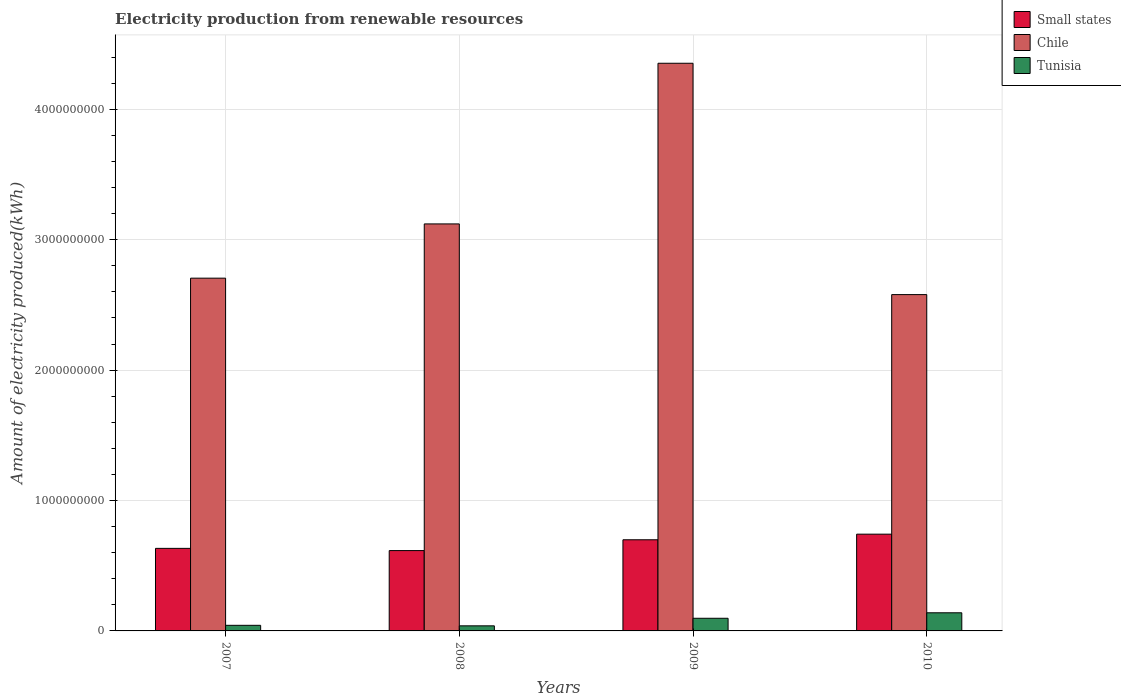How many different coloured bars are there?
Ensure brevity in your answer.  3. How many groups of bars are there?
Provide a short and direct response. 4. How many bars are there on the 2nd tick from the right?
Provide a short and direct response. 3. What is the label of the 1st group of bars from the left?
Your answer should be very brief. 2007. What is the amount of electricity produced in Tunisia in 2008?
Offer a very short reply. 3.90e+07. Across all years, what is the maximum amount of electricity produced in Tunisia?
Ensure brevity in your answer.  1.39e+08. Across all years, what is the minimum amount of electricity produced in Chile?
Your answer should be compact. 2.58e+09. In which year was the amount of electricity produced in Chile maximum?
Your answer should be compact. 2009. What is the total amount of electricity produced in Chile in the graph?
Offer a terse response. 1.28e+1. What is the difference between the amount of electricity produced in Tunisia in 2008 and that in 2009?
Offer a very short reply. -5.80e+07. What is the difference between the amount of electricity produced in Small states in 2008 and the amount of electricity produced in Tunisia in 2009?
Provide a succinct answer. 5.19e+08. What is the average amount of electricity produced in Small states per year?
Offer a terse response. 6.72e+08. In the year 2008, what is the difference between the amount of electricity produced in Small states and amount of electricity produced in Chile?
Your response must be concise. -2.50e+09. What is the ratio of the amount of electricity produced in Small states in 2008 to that in 2010?
Offer a very short reply. 0.83. Is the difference between the amount of electricity produced in Small states in 2008 and 2010 greater than the difference between the amount of electricity produced in Chile in 2008 and 2010?
Your answer should be compact. No. What is the difference between the highest and the second highest amount of electricity produced in Tunisia?
Provide a short and direct response. 4.20e+07. What is the difference between the highest and the lowest amount of electricity produced in Small states?
Provide a short and direct response. 1.26e+08. Is the sum of the amount of electricity produced in Tunisia in 2008 and 2009 greater than the maximum amount of electricity produced in Small states across all years?
Ensure brevity in your answer.  No. What does the 3rd bar from the left in 2009 represents?
Your answer should be very brief. Tunisia. What is the difference between two consecutive major ticks on the Y-axis?
Make the answer very short. 1.00e+09. How many legend labels are there?
Your answer should be very brief. 3. What is the title of the graph?
Offer a terse response. Electricity production from renewable resources. Does "Afghanistan" appear as one of the legend labels in the graph?
Ensure brevity in your answer.  No. What is the label or title of the X-axis?
Your answer should be compact. Years. What is the label or title of the Y-axis?
Offer a very short reply. Amount of electricity produced(kWh). What is the Amount of electricity produced(kWh) of Small states in 2007?
Ensure brevity in your answer.  6.33e+08. What is the Amount of electricity produced(kWh) in Chile in 2007?
Offer a terse response. 2.70e+09. What is the Amount of electricity produced(kWh) in Tunisia in 2007?
Your answer should be compact. 4.30e+07. What is the Amount of electricity produced(kWh) of Small states in 2008?
Your answer should be compact. 6.16e+08. What is the Amount of electricity produced(kWh) in Chile in 2008?
Your answer should be very brief. 3.12e+09. What is the Amount of electricity produced(kWh) in Tunisia in 2008?
Your answer should be compact. 3.90e+07. What is the Amount of electricity produced(kWh) of Small states in 2009?
Provide a short and direct response. 6.99e+08. What is the Amount of electricity produced(kWh) of Chile in 2009?
Your answer should be compact. 4.35e+09. What is the Amount of electricity produced(kWh) of Tunisia in 2009?
Keep it short and to the point. 9.70e+07. What is the Amount of electricity produced(kWh) in Small states in 2010?
Give a very brief answer. 7.42e+08. What is the Amount of electricity produced(kWh) of Chile in 2010?
Offer a very short reply. 2.58e+09. What is the Amount of electricity produced(kWh) of Tunisia in 2010?
Give a very brief answer. 1.39e+08. Across all years, what is the maximum Amount of electricity produced(kWh) of Small states?
Your response must be concise. 7.42e+08. Across all years, what is the maximum Amount of electricity produced(kWh) of Chile?
Keep it short and to the point. 4.35e+09. Across all years, what is the maximum Amount of electricity produced(kWh) of Tunisia?
Give a very brief answer. 1.39e+08. Across all years, what is the minimum Amount of electricity produced(kWh) of Small states?
Offer a very short reply. 6.16e+08. Across all years, what is the minimum Amount of electricity produced(kWh) in Chile?
Give a very brief answer. 2.58e+09. Across all years, what is the minimum Amount of electricity produced(kWh) of Tunisia?
Offer a terse response. 3.90e+07. What is the total Amount of electricity produced(kWh) in Small states in the graph?
Offer a very short reply. 2.69e+09. What is the total Amount of electricity produced(kWh) of Chile in the graph?
Provide a short and direct response. 1.28e+1. What is the total Amount of electricity produced(kWh) in Tunisia in the graph?
Provide a succinct answer. 3.18e+08. What is the difference between the Amount of electricity produced(kWh) of Small states in 2007 and that in 2008?
Your answer should be very brief. 1.70e+07. What is the difference between the Amount of electricity produced(kWh) of Chile in 2007 and that in 2008?
Your answer should be very brief. -4.16e+08. What is the difference between the Amount of electricity produced(kWh) of Small states in 2007 and that in 2009?
Your answer should be very brief. -6.60e+07. What is the difference between the Amount of electricity produced(kWh) of Chile in 2007 and that in 2009?
Offer a very short reply. -1.65e+09. What is the difference between the Amount of electricity produced(kWh) of Tunisia in 2007 and that in 2009?
Provide a succinct answer. -5.40e+07. What is the difference between the Amount of electricity produced(kWh) of Small states in 2007 and that in 2010?
Your answer should be very brief. -1.09e+08. What is the difference between the Amount of electricity produced(kWh) of Chile in 2007 and that in 2010?
Offer a terse response. 1.26e+08. What is the difference between the Amount of electricity produced(kWh) in Tunisia in 2007 and that in 2010?
Offer a very short reply. -9.60e+07. What is the difference between the Amount of electricity produced(kWh) in Small states in 2008 and that in 2009?
Keep it short and to the point. -8.30e+07. What is the difference between the Amount of electricity produced(kWh) of Chile in 2008 and that in 2009?
Provide a short and direct response. -1.23e+09. What is the difference between the Amount of electricity produced(kWh) of Tunisia in 2008 and that in 2009?
Your answer should be compact. -5.80e+07. What is the difference between the Amount of electricity produced(kWh) in Small states in 2008 and that in 2010?
Your response must be concise. -1.26e+08. What is the difference between the Amount of electricity produced(kWh) in Chile in 2008 and that in 2010?
Provide a short and direct response. 5.42e+08. What is the difference between the Amount of electricity produced(kWh) of Tunisia in 2008 and that in 2010?
Offer a terse response. -1.00e+08. What is the difference between the Amount of electricity produced(kWh) in Small states in 2009 and that in 2010?
Your response must be concise. -4.30e+07. What is the difference between the Amount of electricity produced(kWh) of Chile in 2009 and that in 2010?
Give a very brief answer. 1.77e+09. What is the difference between the Amount of electricity produced(kWh) of Tunisia in 2009 and that in 2010?
Provide a short and direct response. -4.20e+07. What is the difference between the Amount of electricity produced(kWh) in Small states in 2007 and the Amount of electricity produced(kWh) in Chile in 2008?
Offer a very short reply. -2.49e+09. What is the difference between the Amount of electricity produced(kWh) in Small states in 2007 and the Amount of electricity produced(kWh) in Tunisia in 2008?
Provide a short and direct response. 5.94e+08. What is the difference between the Amount of electricity produced(kWh) in Chile in 2007 and the Amount of electricity produced(kWh) in Tunisia in 2008?
Give a very brief answer. 2.67e+09. What is the difference between the Amount of electricity produced(kWh) of Small states in 2007 and the Amount of electricity produced(kWh) of Chile in 2009?
Offer a very short reply. -3.72e+09. What is the difference between the Amount of electricity produced(kWh) of Small states in 2007 and the Amount of electricity produced(kWh) of Tunisia in 2009?
Offer a very short reply. 5.36e+08. What is the difference between the Amount of electricity produced(kWh) in Chile in 2007 and the Amount of electricity produced(kWh) in Tunisia in 2009?
Your response must be concise. 2.61e+09. What is the difference between the Amount of electricity produced(kWh) of Small states in 2007 and the Amount of electricity produced(kWh) of Chile in 2010?
Your answer should be very brief. -1.95e+09. What is the difference between the Amount of electricity produced(kWh) in Small states in 2007 and the Amount of electricity produced(kWh) in Tunisia in 2010?
Your answer should be very brief. 4.94e+08. What is the difference between the Amount of electricity produced(kWh) of Chile in 2007 and the Amount of electricity produced(kWh) of Tunisia in 2010?
Your answer should be very brief. 2.57e+09. What is the difference between the Amount of electricity produced(kWh) in Small states in 2008 and the Amount of electricity produced(kWh) in Chile in 2009?
Provide a succinct answer. -3.74e+09. What is the difference between the Amount of electricity produced(kWh) of Small states in 2008 and the Amount of electricity produced(kWh) of Tunisia in 2009?
Provide a short and direct response. 5.19e+08. What is the difference between the Amount of electricity produced(kWh) of Chile in 2008 and the Amount of electricity produced(kWh) of Tunisia in 2009?
Offer a very short reply. 3.02e+09. What is the difference between the Amount of electricity produced(kWh) in Small states in 2008 and the Amount of electricity produced(kWh) in Chile in 2010?
Your answer should be very brief. -1.96e+09. What is the difference between the Amount of electricity produced(kWh) in Small states in 2008 and the Amount of electricity produced(kWh) in Tunisia in 2010?
Give a very brief answer. 4.77e+08. What is the difference between the Amount of electricity produced(kWh) in Chile in 2008 and the Amount of electricity produced(kWh) in Tunisia in 2010?
Provide a short and direct response. 2.98e+09. What is the difference between the Amount of electricity produced(kWh) in Small states in 2009 and the Amount of electricity produced(kWh) in Chile in 2010?
Your answer should be very brief. -1.88e+09. What is the difference between the Amount of electricity produced(kWh) in Small states in 2009 and the Amount of electricity produced(kWh) in Tunisia in 2010?
Offer a very short reply. 5.60e+08. What is the difference between the Amount of electricity produced(kWh) of Chile in 2009 and the Amount of electricity produced(kWh) of Tunisia in 2010?
Keep it short and to the point. 4.21e+09. What is the average Amount of electricity produced(kWh) of Small states per year?
Your answer should be very brief. 6.72e+08. What is the average Amount of electricity produced(kWh) of Chile per year?
Provide a succinct answer. 3.19e+09. What is the average Amount of electricity produced(kWh) in Tunisia per year?
Your answer should be compact. 7.95e+07. In the year 2007, what is the difference between the Amount of electricity produced(kWh) of Small states and Amount of electricity produced(kWh) of Chile?
Your answer should be compact. -2.07e+09. In the year 2007, what is the difference between the Amount of electricity produced(kWh) of Small states and Amount of electricity produced(kWh) of Tunisia?
Give a very brief answer. 5.90e+08. In the year 2007, what is the difference between the Amount of electricity produced(kWh) of Chile and Amount of electricity produced(kWh) of Tunisia?
Your answer should be compact. 2.66e+09. In the year 2008, what is the difference between the Amount of electricity produced(kWh) in Small states and Amount of electricity produced(kWh) in Chile?
Provide a succinct answer. -2.50e+09. In the year 2008, what is the difference between the Amount of electricity produced(kWh) in Small states and Amount of electricity produced(kWh) in Tunisia?
Provide a succinct answer. 5.77e+08. In the year 2008, what is the difference between the Amount of electricity produced(kWh) in Chile and Amount of electricity produced(kWh) in Tunisia?
Give a very brief answer. 3.08e+09. In the year 2009, what is the difference between the Amount of electricity produced(kWh) of Small states and Amount of electricity produced(kWh) of Chile?
Your answer should be compact. -3.65e+09. In the year 2009, what is the difference between the Amount of electricity produced(kWh) in Small states and Amount of electricity produced(kWh) in Tunisia?
Your answer should be very brief. 6.02e+08. In the year 2009, what is the difference between the Amount of electricity produced(kWh) of Chile and Amount of electricity produced(kWh) of Tunisia?
Provide a succinct answer. 4.26e+09. In the year 2010, what is the difference between the Amount of electricity produced(kWh) of Small states and Amount of electricity produced(kWh) of Chile?
Offer a very short reply. -1.84e+09. In the year 2010, what is the difference between the Amount of electricity produced(kWh) in Small states and Amount of electricity produced(kWh) in Tunisia?
Offer a terse response. 6.03e+08. In the year 2010, what is the difference between the Amount of electricity produced(kWh) of Chile and Amount of electricity produced(kWh) of Tunisia?
Ensure brevity in your answer.  2.44e+09. What is the ratio of the Amount of electricity produced(kWh) of Small states in 2007 to that in 2008?
Keep it short and to the point. 1.03. What is the ratio of the Amount of electricity produced(kWh) of Chile in 2007 to that in 2008?
Your response must be concise. 0.87. What is the ratio of the Amount of electricity produced(kWh) in Tunisia in 2007 to that in 2008?
Ensure brevity in your answer.  1.1. What is the ratio of the Amount of electricity produced(kWh) of Small states in 2007 to that in 2009?
Provide a succinct answer. 0.91. What is the ratio of the Amount of electricity produced(kWh) of Chile in 2007 to that in 2009?
Provide a succinct answer. 0.62. What is the ratio of the Amount of electricity produced(kWh) of Tunisia in 2007 to that in 2009?
Your response must be concise. 0.44. What is the ratio of the Amount of electricity produced(kWh) in Small states in 2007 to that in 2010?
Provide a short and direct response. 0.85. What is the ratio of the Amount of electricity produced(kWh) in Chile in 2007 to that in 2010?
Provide a short and direct response. 1.05. What is the ratio of the Amount of electricity produced(kWh) in Tunisia in 2007 to that in 2010?
Offer a very short reply. 0.31. What is the ratio of the Amount of electricity produced(kWh) in Small states in 2008 to that in 2009?
Give a very brief answer. 0.88. What is the ratio of the Amount of electricity produced(kWh) of Chile in 2008 to that in 2009?
Provide a succinct answer. 0.72. What is the ratio of the Amount of electricity produced(kWh) in Tunisia in 2008 to that in 2009?
Offer a very short reply. 0.4. What is the ratio of the Amount of electricity produced(kWh) in Small states in 2008 to that in 2010?
Make the answer very short. 0.83. What is the ratio of the Amount of electricity produced(kWh) in Chile in 2008 to that in 2010?
Your response must be concise. 1.21. What is the ratio of the Amount of electricity produced(kWh) in Tunisia in 2008 to that in 2010?
Make the answer very short. 0.28. What is the ratio of the Amount of electricity produced(kWh) of Small states in 2009 to that in 2010?
Make the answer very short. 0.94. What is the ratio of the Amount of electricity produced(kWh) in Chile in 2009 to that in 2010?
Your answer should be compact. 1.69. What is the ratio of the Amount of electricity produced(kWh) of Tunisia in 2009 to that in 2010?
Provide a short and direct response. 0.7. What is the difference between the highest and the second highest Amount of electricity produced(kWh) in Small states?
Offer a terse response. 4.30e+07. What is the difference between the highest and the second highest Amount of electricity produced(kWh) in Chile?
Ensure brevity in your answer.  1.23e+09. What is the difference between the highest and the second highest Amount of electricity produced(kWh) of Tunisia?
Provide a succinct answer. 4.20e+07. What is the difference between the highest and the lowest Amount of electricity produced(kWh) of Small states?
Provide a succinct answer. 1.26e+08. What is the difference between the highest and the lowest Amount of electricity produced(kWh) of Chile?
Give a very brief answer. 1.77e+09. 